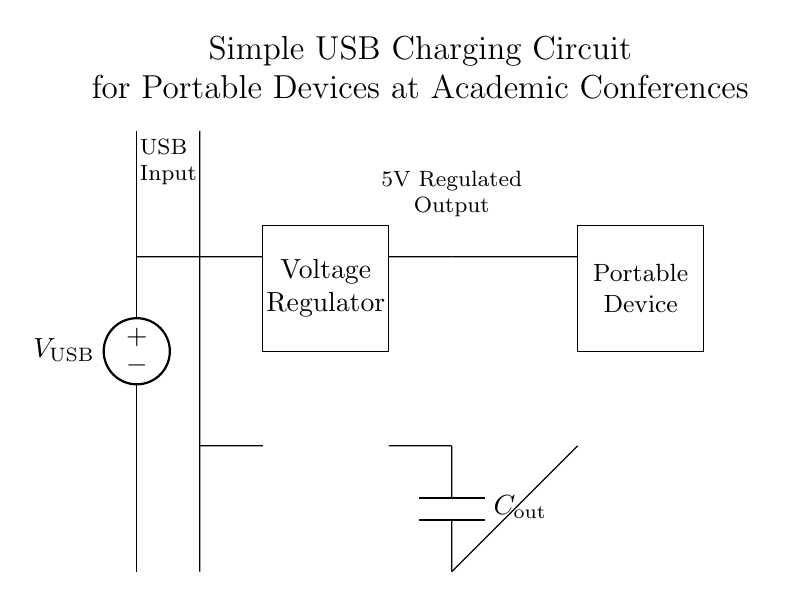what type of voltage source is used? The circuit uses an American voltage source, indicated by the specific symbol for this type of voltage source in the diagram.
Answer: American voltage source what is the output voltage of the circuit? The output of the voltage regulator provides a regulated output of 5 volts, which is a typical output for USB chargers.
Answer: 5 volts how many main components are visible in the circuit? The circuit diagram displays four main components: the voltage source, voltage regulator, output capacitor, and load (portable device).
Answer: four what is the purpose of the capacitor in this circuit? The capacitor (C_out) is used to smooth out the output voltage from the voltage regulator, ensuring stable operation for the connected portable device.
Answer: smooth output voltage what is the load in this circuit? The load refers to the portable device connected to the circuit, which is the component intended to receive the power for charging.
Answer: Portable Device what role does the voltage regulator play in this circuit? The voltage regulator converts the input USB voltage to a stable 5V output, which is essential for appropriately charging the portable device without damage.
Answer: stabilizes voltage to 5V how is the output capacitor connected in the circuit? The output capacitor is connected between the output of the voltage regulator and ground, which allows it to filter and stabilize the output voltage before reaching the load.
Answer: Between the regulator and ground 